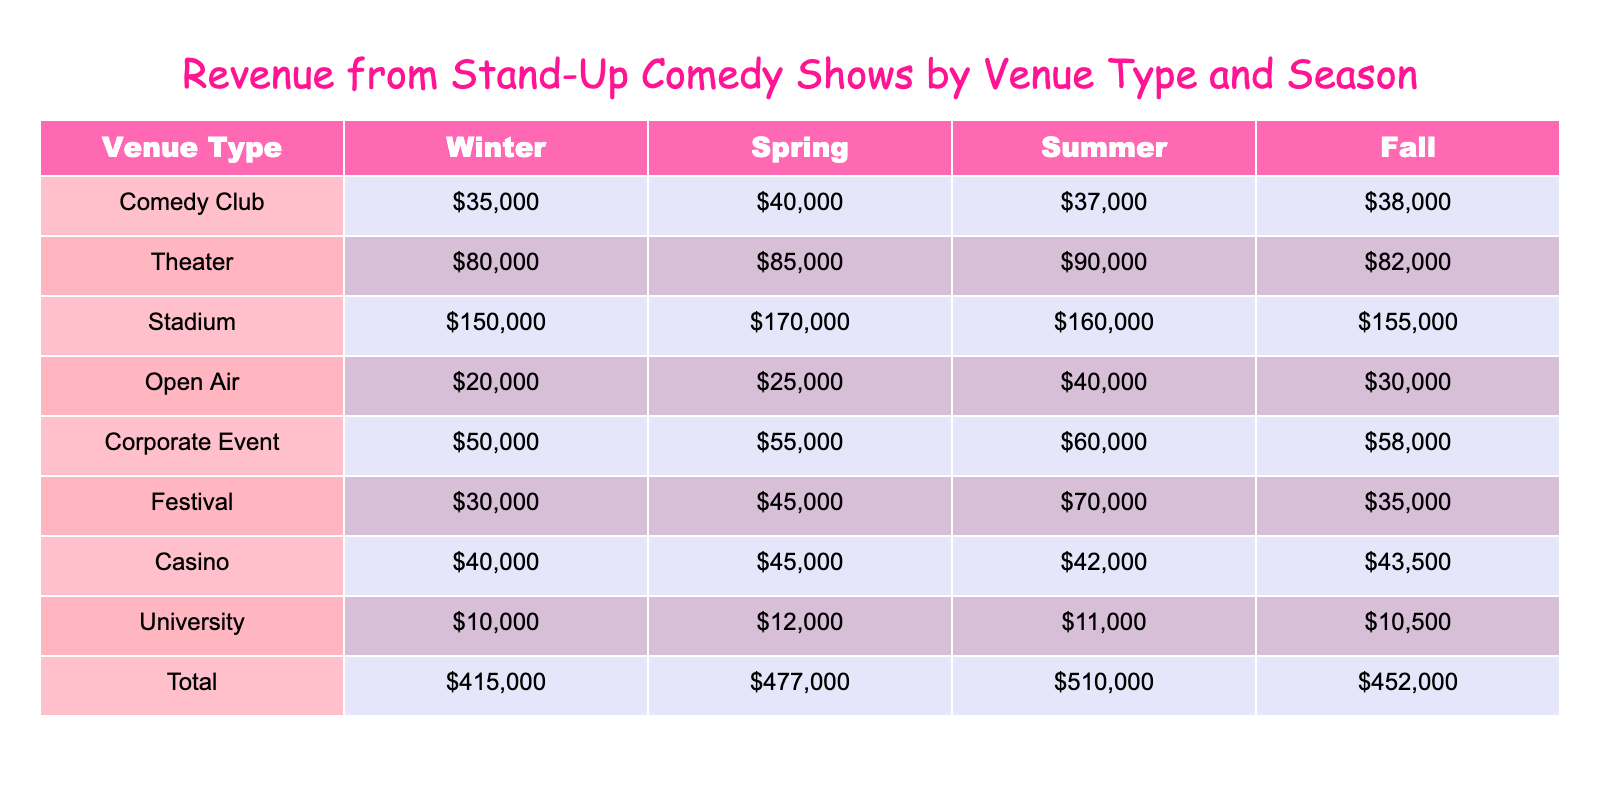What is the total revenue generated in the Spring season across all venue types? To find the total revenue for Spring, I need to find the revenue from each venue type during Spring and then sum them up. The venue revenues for Spring are: Comedy Club ($40,000), Theater ($85,000), Stadium ($170,000), Open Air ($25,000), Corporate Event ($55,000), Festival ($45,000), Casino ($45,000), and University ($12,000). Adding these values gives: 40000 + 85000 + 170000 + 25000 + 55000 + 45000 + 45000 + 12000 = 435000.
Answer: 435000 Which venue type had the highest revenue in the Summer season? To determine which venue had the highest revenue in Summer, I look at the Summer revenues for each venue. They are: Comedy Club ($37,000), Theater ($90,000), Stadium ($160,000), Open Air ($40,000), Corporate Event ($60,000), Festival ($70,000), Casino ($42,000), and University ($11,000). The highest value is $160,000 from the Stadium.
Answer: Stadium Is the revenue generated from Festivals in the Winter greater than the revenue from Corporate Events in Winter? For this question, I check the Winter revenues for both Festivals and Corporate Events. The revenue for Festivals in Winter is $30,000, and for Corporate Events, it's $50,000. Since $30,000 is less than $50,000, the statement is false.
Answer: False What is the average revenue from Comedy Clubs across all seasons? To calculate the average revenue from Comedy Clubs across all seasons, I need to sum the revenues for Comedy Clubs in each season: Winter ($35,000), Spring ($40,000), Summer ($37,000), and Fall ($38,000). The total revenue is 35000 + 40000 + 37000 + 38000 = 154000, and there are 4 seasons, so the average revenue is 154000 / 4 = 38500.
Answer: 38500 How much more revenue does the Stadium generate in Spring compared to the Theater in Spring? To find this, I look at the Spring revenues for both venues. The Stadium generates $170,000, while the Theater generates $85,000. The difference is $170,000 - $85,000 = $85,000, meaning the Stadium generates $85,000 more than the Theater in the Spring.
Answer: 85000 